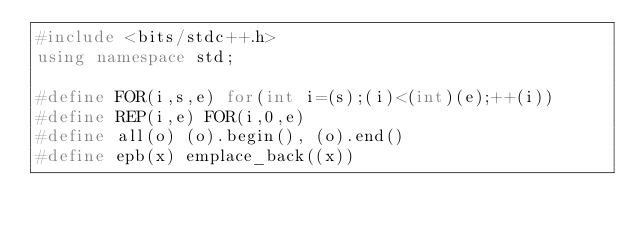Convert code to text. <code><loc_0><loc_0><loc_500><loc_500><_C++_>#include <bits/stdc++.h>
using namespace std;

#define FOR(i,s,e) for(int i=(s);(i)<(int)(e);++(i))
#define REP(i,e) FOR(i,0,e)
#define all(o) (o).begin(), (o).end()
#define epb(x) emplace_back((x))</code> 